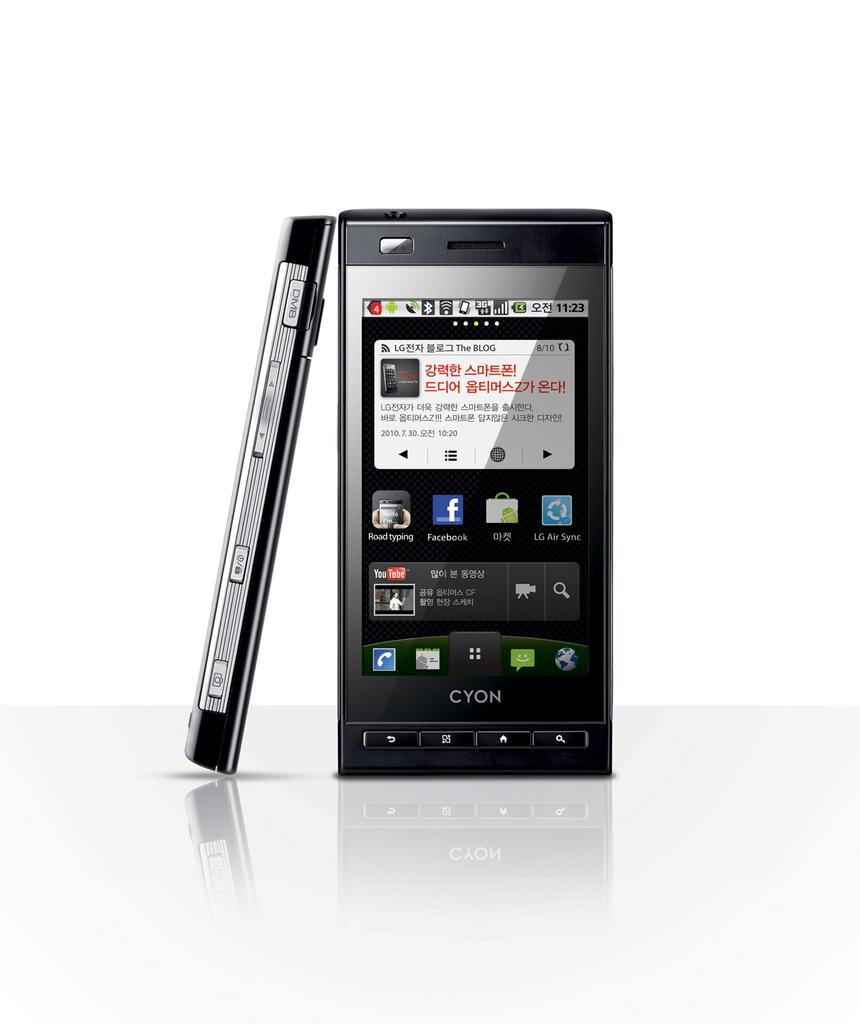<image>
Offer a succinct explanation of the picture presented. A Cyon cell phone has the time listed at 11:23. 